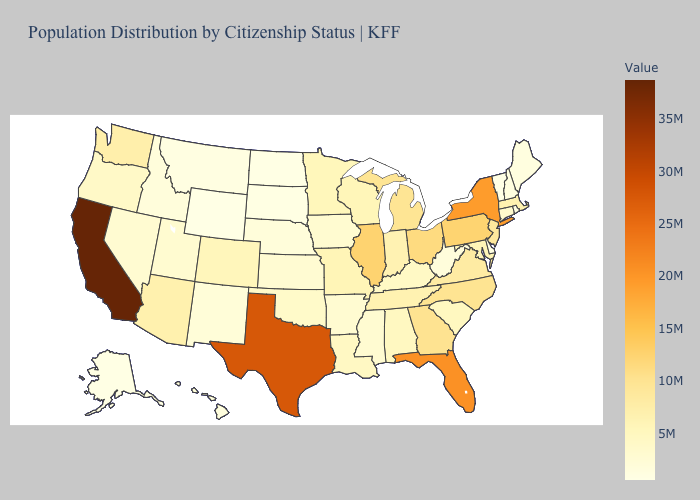Does Michigan have the lowest value in the MidWest?
Be succinct. No. Among the states that border Michigan , does Wisconsin have the highest value?
Answer briefly. No. Among the states that border Idaho , which have the lowest value?
Answer briefly. Wyoming. Does Hawaii have the lowest value in the USA?
Concise answer only. No. 